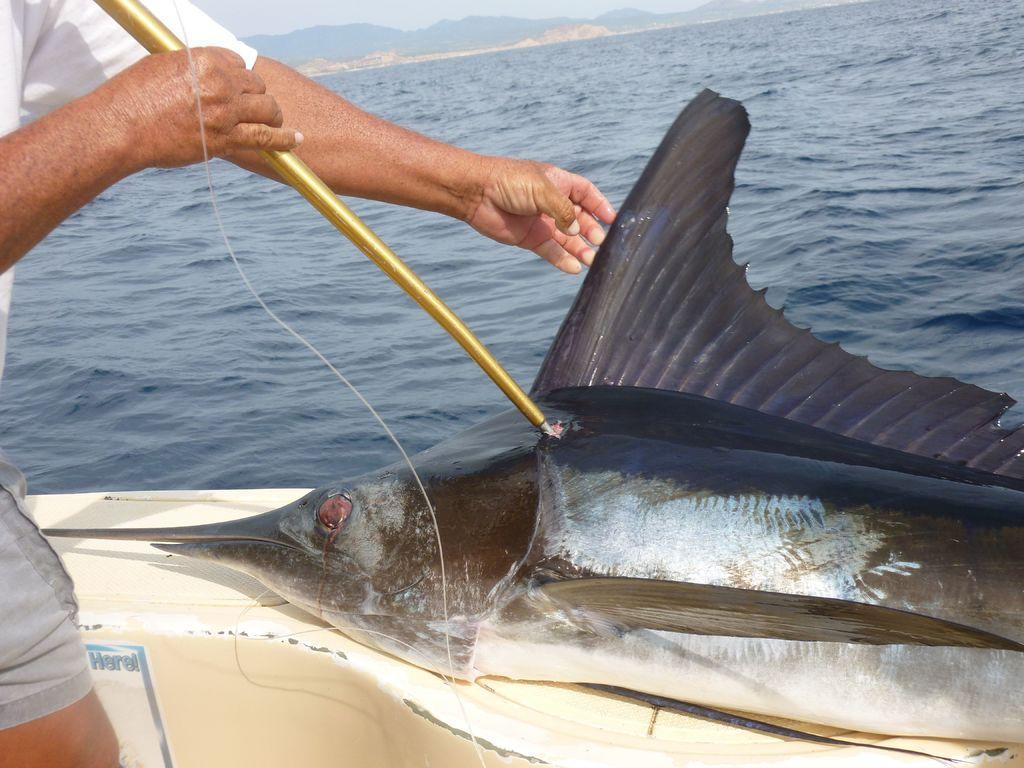Describe this image in one or two sentences. The picture consists of a fish. On the left there is a person holding a blade, the blade is pierced into the fish. In the center of the picture there is a water body. In the background there are hills. 